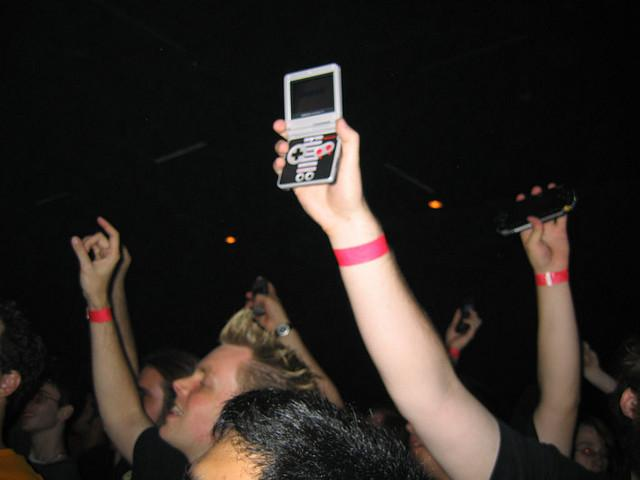The bottom portion of the screen that is furthest to the front looks like what video game controller? nintendo 